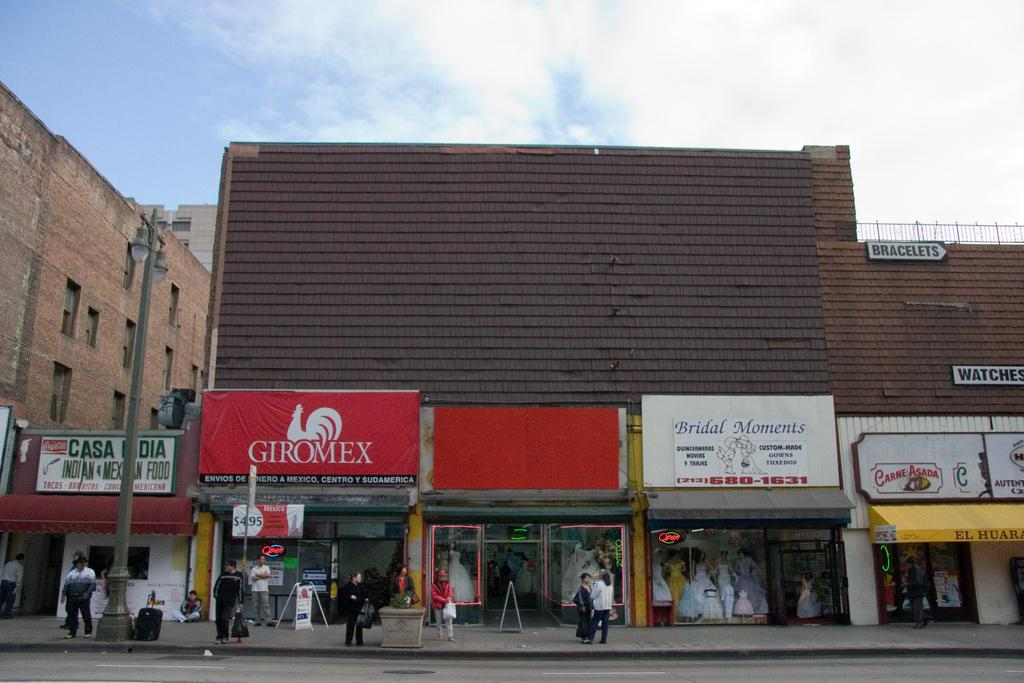<image>
Offer a succinct explanation of the picture presented. A series of store fronts, one of which is called Bridal Moments. 